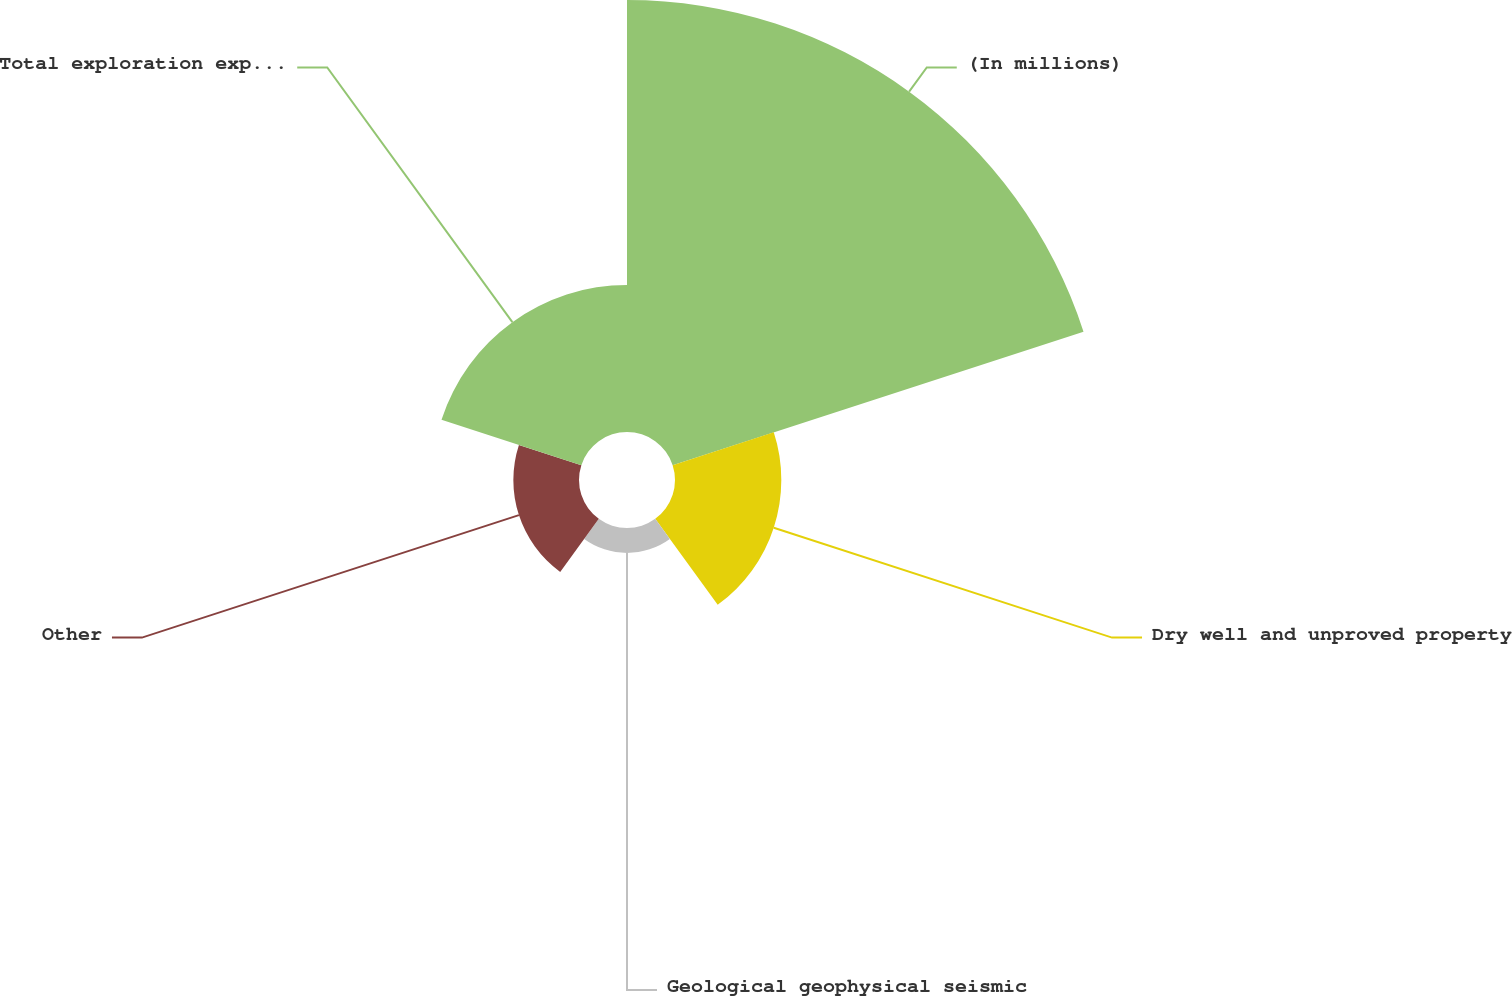Convert chart. <chart><loc_0><loc_0><loc_500><loc_500><pie_chart><fcel>(In millions)<fcel>Dry well and unproved property<fcel>Geological geophysical seismic<fcel>Other<fcel>Total exploration expenses<nl><fcel>55.67%<fcel>13.7%<fcel>3.21%<fcel>8.46%<fcel>18.95%<nl></chart> 